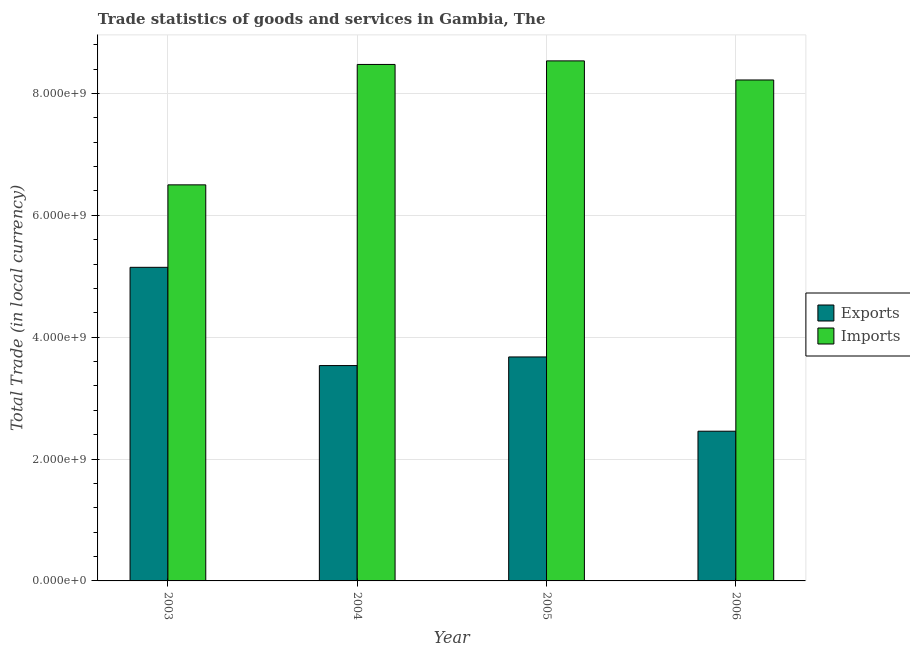How many groups of bars are there?
Make the answer very short. 4. Are the number of bars per tick equal to the number of legend labels?
Ensure brevity in your answer.  Yes. How many bars are there on the 3rd tick from the left?
Your answer should be compact. 2. How many bars are there on the 4th tick from the right?
Ensure brevity in your answer.  2. In how many cases, is the number of bars for a given year not equal to the number of legend labels?
Ensure brevity in your answer.  0. What is the export of goods and services in 2003?
Give a very brief answer. 5.15e+09. Across all years, what is the maximum imports of goods and services?
Make the answer very short. 8.53e+09. Across all years, what is the minimum export of goods and services?
Offer a terse response. 2.46e+09. In which year was the export of goods and services minimum?
Ensure brevity in your answer.  2006. What is the total export of goods and services in the graph?
Provide a succinct answer. 1.48e+1. What is the difference between the imports of goods and services in 2005 and that in 2006?
Your answer should be compact. 3.13e+08. What is the difference between the export of goods and services in 2006 and the imports of goods and services in 2004?
Your response must be concise. -1.08e+09. What is the average imports of goods and services per year?
Offer a terse response. 7.93e+09. In the year 2006, what is the difference between the imports of goods and services and export of goods and services?
Your response must be concise. 0. In how many years, is the imports of goods and services greater than 1200000000 LCU?
Offer a terse response. 4. What is the ratio of the imports of goods and services in 2003 to that in 2005?
Ensure brevity in your answer.  0.76. What is the difference between the highest and the second highest imports of goods and services?
Offer a terse response. 5.86e+07. What is the difference between the highest and the lowest export of goods and services?
Give a very brief answer. 2.69e+09. Is the sum of the export of goods and services in 2003 and 2006 greater than the maximum imports of goods and services across all years?
Your answer should be very brief. Yes. What does the 2nd bar from the left in 2006 represents?
Your answer should be compact. Imports. What does the 2nd bar from the right in 2005 represents?
Your answer should be compact. Exports. How many bars are there?
Make the answer very short. 8. Are the values on the major ticks of Y-axis written in scientific E-notation?
Offer a terse response. Yes. Does the graph contain any zero values?
Your response must be concise. No. Does the graph contain grids?
Offer a terse response. Yes. What is the title of the graph?
Your answer should be compact. Trade statistics of goods and services in Gambia, The. Does "Under-five" appear as one of the legend labels in the graph?
Offer a terse response. No. What is the label or title of the X-axis?
Offer a very short reply. Year. What is the label or title of the Y-axis?
Provide a short and direct response. Total Trade (in local currency). What is the Total Trade (in local currency) of Exports in 2003?
Provide a short and direct response. 5.15e+09. What is the Total Trade (in local currency) of Imports in 2003?
Make the answer very short. 6.50e+09. What is the Total Trade (in local currency) of Exports in 2004?
Provide a succinct answer. 3.53e+09. What is the Total Trade (in local currency) in Imports in 2004?
Your answer should be very brief. 8.47e+09. What is the Total Trade (in local currency) of Exports in 2005?
Give a very brief answer. 3.68e+09. What is the Total Trade (in local currency) of Imports in 2005?
Offer a very short reply. 8.53e+09. What is the Total Trade (in local currency) in Exports in 2006?
Offer a terse response. 2.46e+09. What is the Total Trade (in local currency) in Imports in 2006?
Your answer should be compact. 8.22e+09. Across all years, what is the maximum Total Trade (in local currency) of Exports?
Offer a terse response. 5.15e+09. Across all years, what is the maximum Total Trade (in local currency) in Imports?
Offer a terse response. 8.53e+09. Across all years, what is the minimum Total Trade (in local currency) of Exports?
Offer a very short reply. 2.46e+09. Across all years, what is the minimum Total Trade (in local currency) in Imports?
Your answer should be compact. 6.50e+09. What is the total Total Trade (in local currency) of Exports in the graph?
Make the answer very short. 1.48e+1. What is the total Total Trade (in local currency) in Imports in the graph?
Make the answer very short. 3.17e+1. What is the difference between the Total Trade (in local currency) in Exports in 2003 and that in 2004?
Offer a very short reply. 1.61e+09. What is the difference between the Total Trade (in local currency) of Imports in 2003 and that in 2004?
Provide a short and direct response. -1.98e+09. What is the difference between the Total Trade (in local currency) of Exports in 2003 and that in 2005?
Offer a terse response. 1.47e+09. What is the difference between the Total Trade (in local currency) in Imports in 2003 and that in 2005?
Your answer should be very brief. -2.03e+09. What is the difference between the Total Trade (in local currency) in Exports in 2003 and that in 2006?
Give a very brief answer. 2.69e+09. What is the difference between the Total Trade (in local currency) of Imports in 2003 and that in 2006?
Your answer should be very brief. -1.72e+09. What is the difference between the Total Trade (in local currency) in Exports in 2004 and that in 2005?
Your answer should be compact. -1.41e+08. What is the difference between the Total Trade (in local currency) in Imports in 2004 and that in 2005?
Ensure brevity in your answer.  -5.86e+07. What is the difference between the Total Trade (in local currency) in Exports in 2004 and that in 2006?
Your answer should be very brief. 1.08e+09. What is the difference between the Total Trade (in local currency) of Imports in 2004 and that in 2006?
Give a very brief answer. 2.55e+08. What is the difference between the Total Trade (in local currency) of Exports in 2005 and that in 2006?
Keep it short and to the point. 1.22e+09. What is the difference between the Total Trade (in local currency) of Imports in 2005 and that in 2006?
Your response must be concise. 3.13e+08. What is the difference between the Total Trade (in local currency) of Exports in 2003 and the Total Trade (in local currency) of Imports in 2004?
Keep it short and to the point. -3.33e+09. What is the difference between the Total Trade (in local currency) in Exports in 2003 and the Total Trade (in local currency) in Imports in 2005?
Give a very brief answer. -3.39e+09. What is the difference between the Total Trade (in local currency) of Exports in 2003 and the Total Trade (in local currency) of Imports in 2006?
Your answer should be compact. -3.07e+09. What is the difference between the Total Trade (in local currency) of Exports in 2004 and the Total Trade (in local currency) of Imports in 2005?
Make the answer very short. -5.00e+09. What is the difference between the Total Trade (in local currency) of Exports in 2004 and the Total Trade (in local currency) of Imports in 2006?
Your answer should be compact. -4.69e+09. What is the difference between the Total Trade (in local currency) of Exports in 2005 and the Total Trade (in local currency) of Imports in 2006?
Your answer should be compact. -4.55e+09. What is the average Total Trade (in local currency) of Exports per year?
Ensure brevity in your answer.  3.70e+09. What is the average Total Trade (in local currency) of Imports per year?
Provide a short and direct response. 7.93e+09. In the year 2003, what is the difference between the Total Trade (in local currency) in Exports and Total Trade (in local currency) in Imports?
Provide a succinct answer. -1.35e+09. In the year 2004, what is the difference between the Total Trade (in local currency) of Exports and Total Trade (in local currency) of Imports?
Ensure brevity in your answer.  -4.94e+09. In the year 2005, what is the difference between the Total Trade (in local currency) in Exports and Total Trade (in local currency) in Imports?
Your response must be concise. -4.86e+09. In the year 2006, what is the difference between the Total Trade (in local currency) of Exports and Total Trade (in local currency) of Imports?
Make the answer very short. -5.76e+09. What is the ratio of the Total Trade (in local currency) of Exports in 2003 to that in 2004?
Provide a short and direct response. 1.46. What is the ratio of the Total Trade (in local currency) of Imports in 2003 to that in 2004?
Offer a terse response. 0.77. What is the ratio of the Total Trade (in local currency) of Exports in 2003 to that in 2005?
Provide a short and direct response. 1.4. What is the ratio of the Total Trade (in local currency) in Imports in 2003 to that in 2005?
Ensure brevity in your answer.  0.76. What is the ratio of the Total Trade (in local currency) of Exports in 2003 to that in 2006?
Provide a short and direct response. 2.09. What is the ratio of the Total Trade (in local currency) in Imports in 2003 to that in 2006?
Give a very brief answer. 0.79. What is the ratio of the Total Trade (in local currency) of Exports in 2004 to that in 2005?
Your response must be concise. 0.96. What is the ratio of the Total Trade (in local currency) of Exports in 2004 to that in 2006?
Keep it short and to the point. 1.44. What is the ratio of the Total Trade (in local currency) of Imports in 2004 to that in 2006?
Your answer should be compact. 1.03. What is the ratio of the Total Trade (in local currency) in Exports in 2005 to that in 2006?
Make the answer very short. 1.5. What is the ratio of the Total Trade (in local currency) in Imports in 2005 to that in 2006?
Your answer should be very brief. 1.04. What is the difference between the highest and the second highest Total Trade (in local currency) of Exports?
Your response must be concise. 1.47e+09. What is the difference between the highest and the second highest Total Trade (in local currency) of Imports?
Give a very brief answer. 5.86e+07. What is the difference between the highest and the lowest Total Trade (in local currency) in Exports?
Ensure brevity in your answer.  2.69e+09. What is the difference between the highest and the lowest Total Trade (in local currency) of Imports?
Keep it short and to the point. 2.03e+09. 